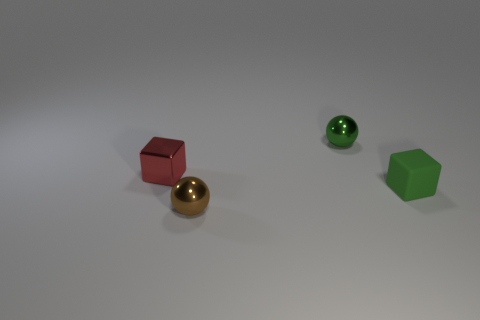Do the green shiny thing and the small object in front of the green rubber cube have the same shape?
Provide a succinct answer. Yes. How many things are either red things or shiny objects left of the small green cube?
Make the answer very short. 3. There is a green object that is the same shape as the tiny brown object; what is its material?
Provide a succinct answer. Metal. There is a green object behind the rubber thing; does it have the same shape as the green matte object?
Provide a succinct answer. No. Is there any other thing that has the same size as the brown object?
Ensure brevity in your answer.  Yes. Are there fewer small red metallic cubes behind the brown object than small red blocks to the right of the tiny green metallic ball?
Your answer should be very brief. No. What number of other objects are the same shape as the red thing?
Provide a succinct answer. 1. What is the size of the green object in front of the tiny shiny sphere behind the matte object to the right of the small green metallic thing?
Your response must be concise. Small. What number of purple things are either matte blocks or metallic blocks?
Ensure brevity in your answer.  0. The tiny brown metallic thing that is left of the tiny sphere behind the tiny red cube is what shape?
Your response must be concise. Sphere. 